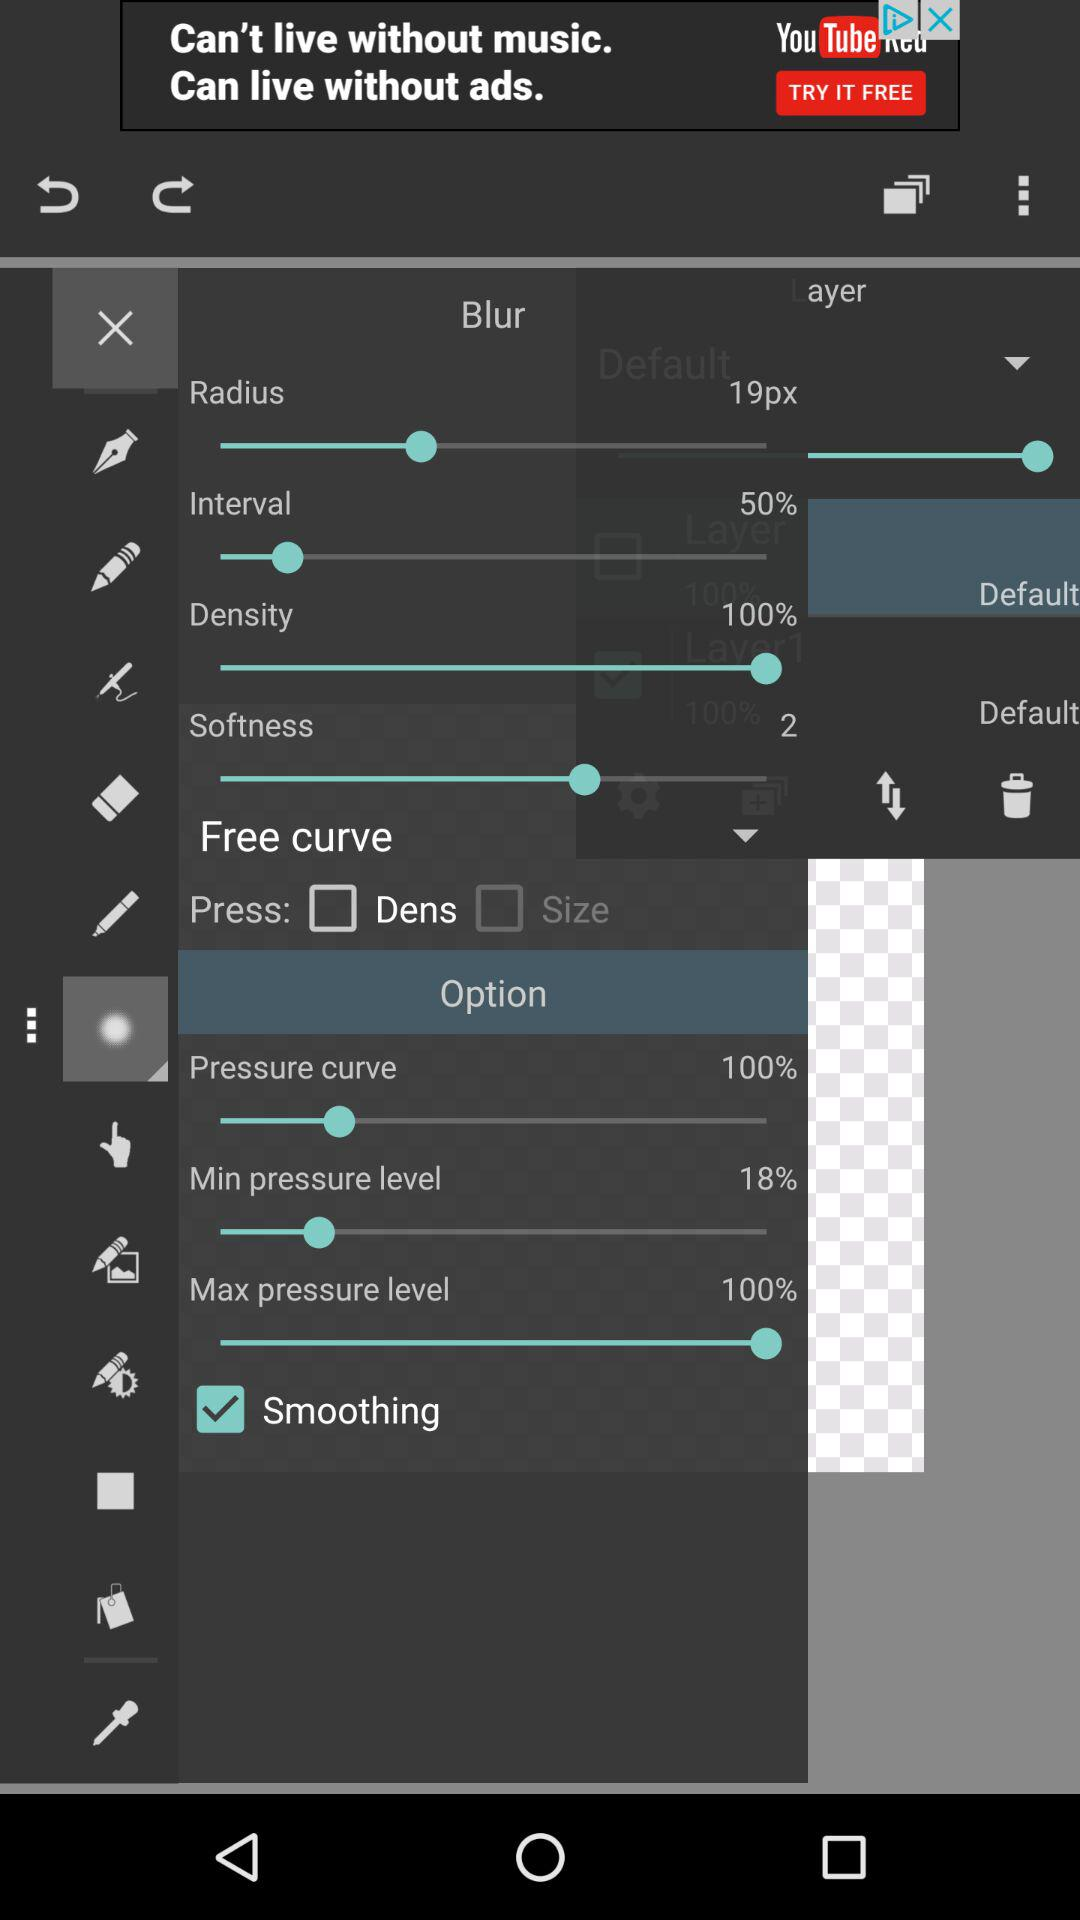What is the size of the radius? The size of the radius is 19 pixels. 